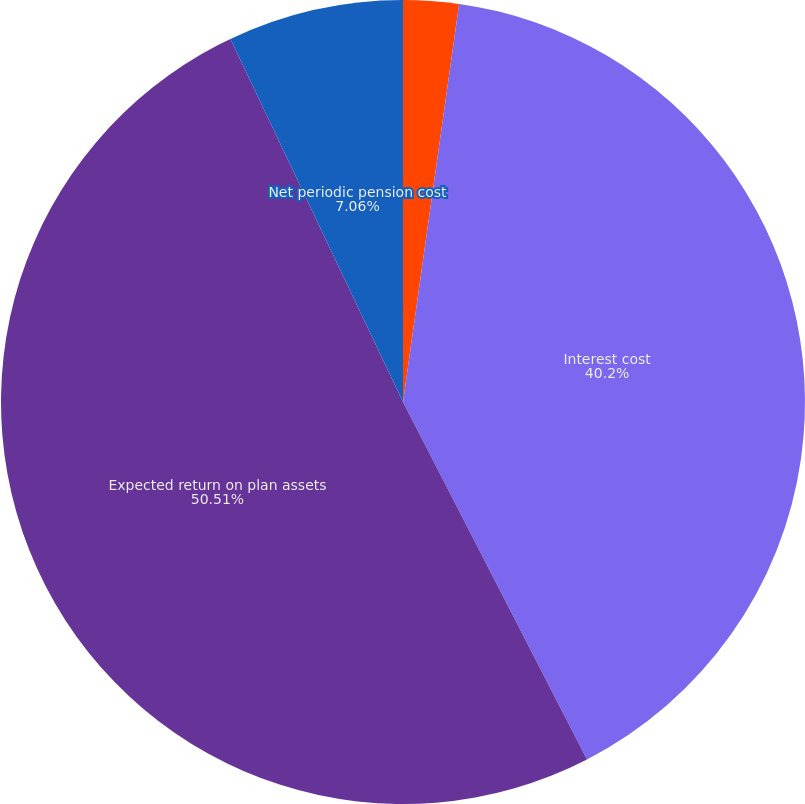Convert chart to OTSL. <chart><loc_0><loc_0><loc_500><loc_500><pie_chart><fcel>Service cost<fcel>Interest cost<fcel>Expected return on plan assets<fcel>Net periodic pension cost<nl><fcel>2.23%<fcel>40.2%<fcel>50.5%<fcel>7.06%<nl></chart> 